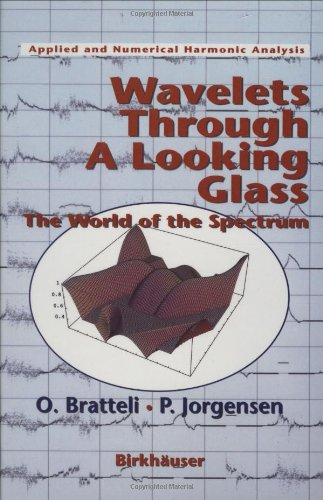What type of book is this? This book is primarily focused on the mathematical and physical aspects of wavelets and spectral theory, fitting best within the categories of mathematics and applied physics rather than just Computers & Technology. 